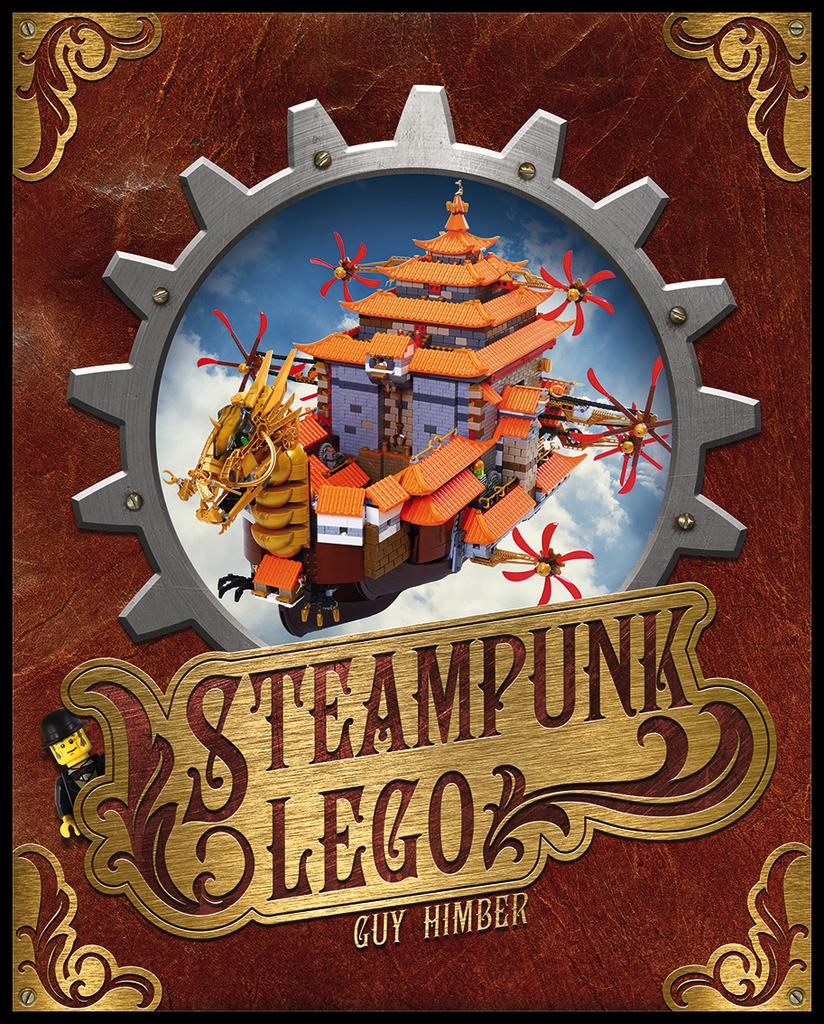What type of legos are they?
Ensure brevity in your answer.  Steampunk. 